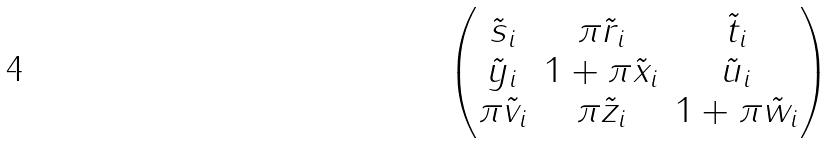Convert formula to latex. <formula><loc_0><loc_0><loc_500><loc_500>\begin{pmatrix} \tilde { s } _ { i } & \pi \tilde { r } _ { i } & \tilde { t } _ { i } \\ \tilde { y } _ { i } & 1 + \pi \tilde { x } _ { i } & \tilde { u } _ { i } \\ \pi \tilde { v } _ { i } & \pi \tilde { z } _ { i } & 1 + \pi \tilde { w } _ { i } \end{pmatrix}</formula> 